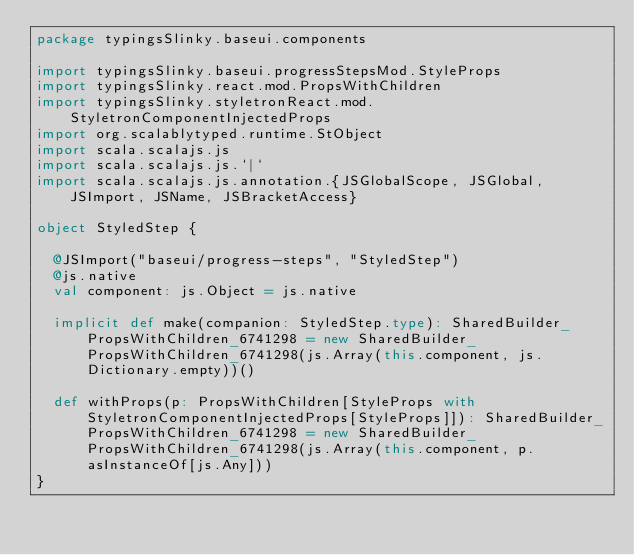Convert code to text. <code><loc_0><loc_0><loc_500><loc_500><_Scala_>package typingsSlinky.baseui.components

import typingsSlinky.baseui.progressStepsMod.StyleProps
import typingsSlinky.react.mod.PropsWithChildren
import typingsSlinky.styletronReact.mod.StyletronComponentInjectedProps
import org.scalablytyped.runtime.StObject
import scala.scalajs.js
import scala.scalajs.js.`|`
import scala.scalajs.js.annotation.{JSGlobalScope, JSGlobal, JSImport, JSName, JSBracketAccess}

object StyledStep {
  
  @JSImport("baseui/progress-steps", "StyledStep")
  @js.native
  val component: js.Object = js.native
  
  implicit def make(companion: StyledStep.type): SharedBuilder_PropsWithChildren_6741298 = new SharedBuilder_PropsWithChildren_6741298(js.Array(this.component, js.Dictionary.empty))()
  
  def withProps(p: PropsWithChildren[StyleProps with StyletronComponentInjectedProps[StyleProps]]): SharedBuilder_PropsWithChildren_6741298 = new SharedBuilder_PropsWithChildren_6741298(js.Array(this.component, p.asInstanceOf[js.Any]))
}
</code> 